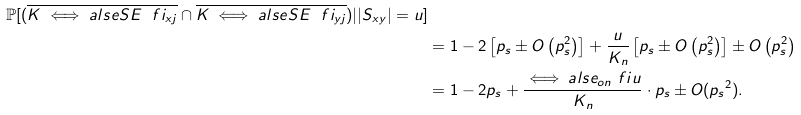Convert formula to latex. <formula><loc_0><loc_0><loc_500><loc_500>{ \mathbb { P } [ ( \overline { K \iff a l s e S E \ f i _ { { x } j } } \cap \overline { K \iff a l s e S E \ f i _ { { y } j } } ) | | S _ { x y } | = u ] } \\ & = 1 - 2 \left [ p _ { s } \pm O \left ( p _ { s } ^ { 2 } \right ) \right ] + \frac { u } { K _ { n } } \left [ p _ { s } \pm O \left ( p _ { s } ^ { 2 } \right ) \right ] \pm O \left ( p _ { s } ^ { 2 } \right ) \\ & = 1 - 2 p _ { s } + \frac { { \iff a l s e _ { o n } \ f i } u } { K _ { n } } \cdot { p _ { s } } \pm O ( { p _ { s } } ^ { 2 } ) .</formula> 